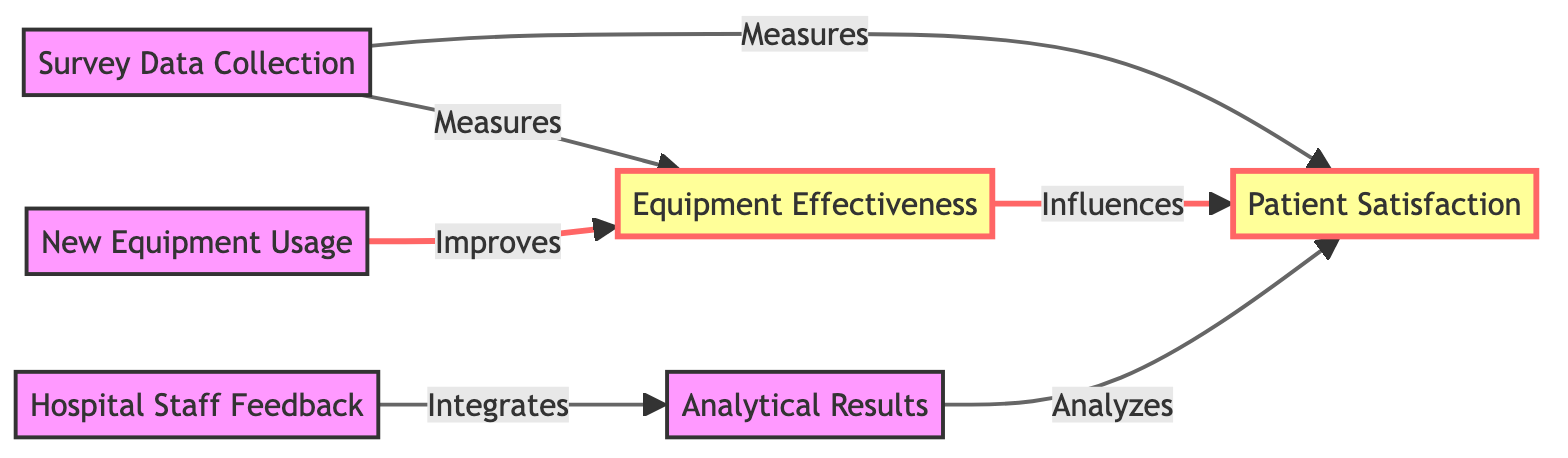What is the first node in the diagram? The first node in the diagram is "Patient Satisfaction," which is positioned at the top of the flowchart.
Answer: Patient Satisfaction How many nodes are in the diagram? The diagram contains a total of six nodes: "Patient Satisfaction," "Equipment Effectiveness," "Survey Data Collection," "New Equipment Usage," "Hospital Staff Feedback," and "Analytical Results."
Answer: Six What does "New Equipment Usage" improve? "New Equipment Usage" improves "Equipment Effectiveness," as indicated by the directional arrow labeled "Improves" leading from "New Equipment Usage" to "Equipment Effectiveness."
Answer: Equipment Effectiveness What influences "Patient Satisfaction"? "Equipment Effectiveness" influences "Patient Satisfaction," as shown by the directional arrow labeled "Influences" going from "Equipment Effectiveness" to "Patient Satisfaction."
Answer: Equipment Effectiveness Which node integrates with analytical results? "Hospital Staff Feedback" integrates with "Analytical Results," as indicated by the link labeled "Integrates" leading from "Hospital Staff Feedback" to "Analytical Results."
Answer: Hospital Staff Feedback What is measured by "Survey Data Collection"? "Survey Data Collection" measures both "Patient Satisfaction" and "Equipment Effectiveness," shown by the two arrows that branch from "Survey Data Collection" to each of those nodes respectively.
Answer: Patient Satisfaction and Equipment Effectiveness How is "Patient Satisfaction" analyzed? "Patient Satisfaction" is analyzed by "Analytical Results," with a directional link labeled "Analyzes" connecting "Analytical Results" to "Patient Satisfaction."
Answer: Analytical Results What is the relationship between "Equipment Effectiveness" and "Patient Satisfaction"? "Equipment Effectiveness" influences "Patient Satisfaction," as shown by the arrow with the label "Influences" that connects these two nodes.
Answer: Influences What connects "Survey Data Collection" to "Patient Satisfaction"? "Survey Data Collection" connects to "Patient Satisfaction" through the relationship labeled "Measures," indicating that the survey data is a method of assessing patient satisfaction.
Answer: Measures 